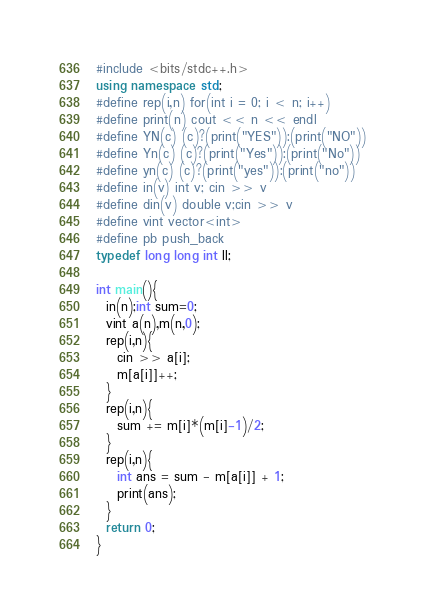Convert code to text. <code><loc_0><loc_0><loc_500><loc_500><_C++_>#include <bits/stdc++.h>
using namespace std;
#define rep(i,n) for(int i = 0; i < n; i++)
#define print(n) cout << n << endl
#define YN(c) (c)?(print("YES")):(print("NO"))
#define Yn(c) (c)?(print("Yes")):(print("No"))
#define yn(c) (c)?(print("yes")):(print("no"))
#define in(v) int v; cin >> v
#define din(v) double v;cin >> v
#define vint vector<int>
#define pb push_back
typedef long long int ll;

int main(){
  in(n);int sum=0;
  vint a(n),m(n,0);
  rep(i,n){
    cin >> a[i];
    m[a[i]]++;
  }
  rep(i,n){
    sum += m[i]*(m[i]-1)/2;
  }
  rep(i,n){
    int ans = sum - m[a[i]] + 1;
    print(ans);
  }
  return 0;
}</code> 